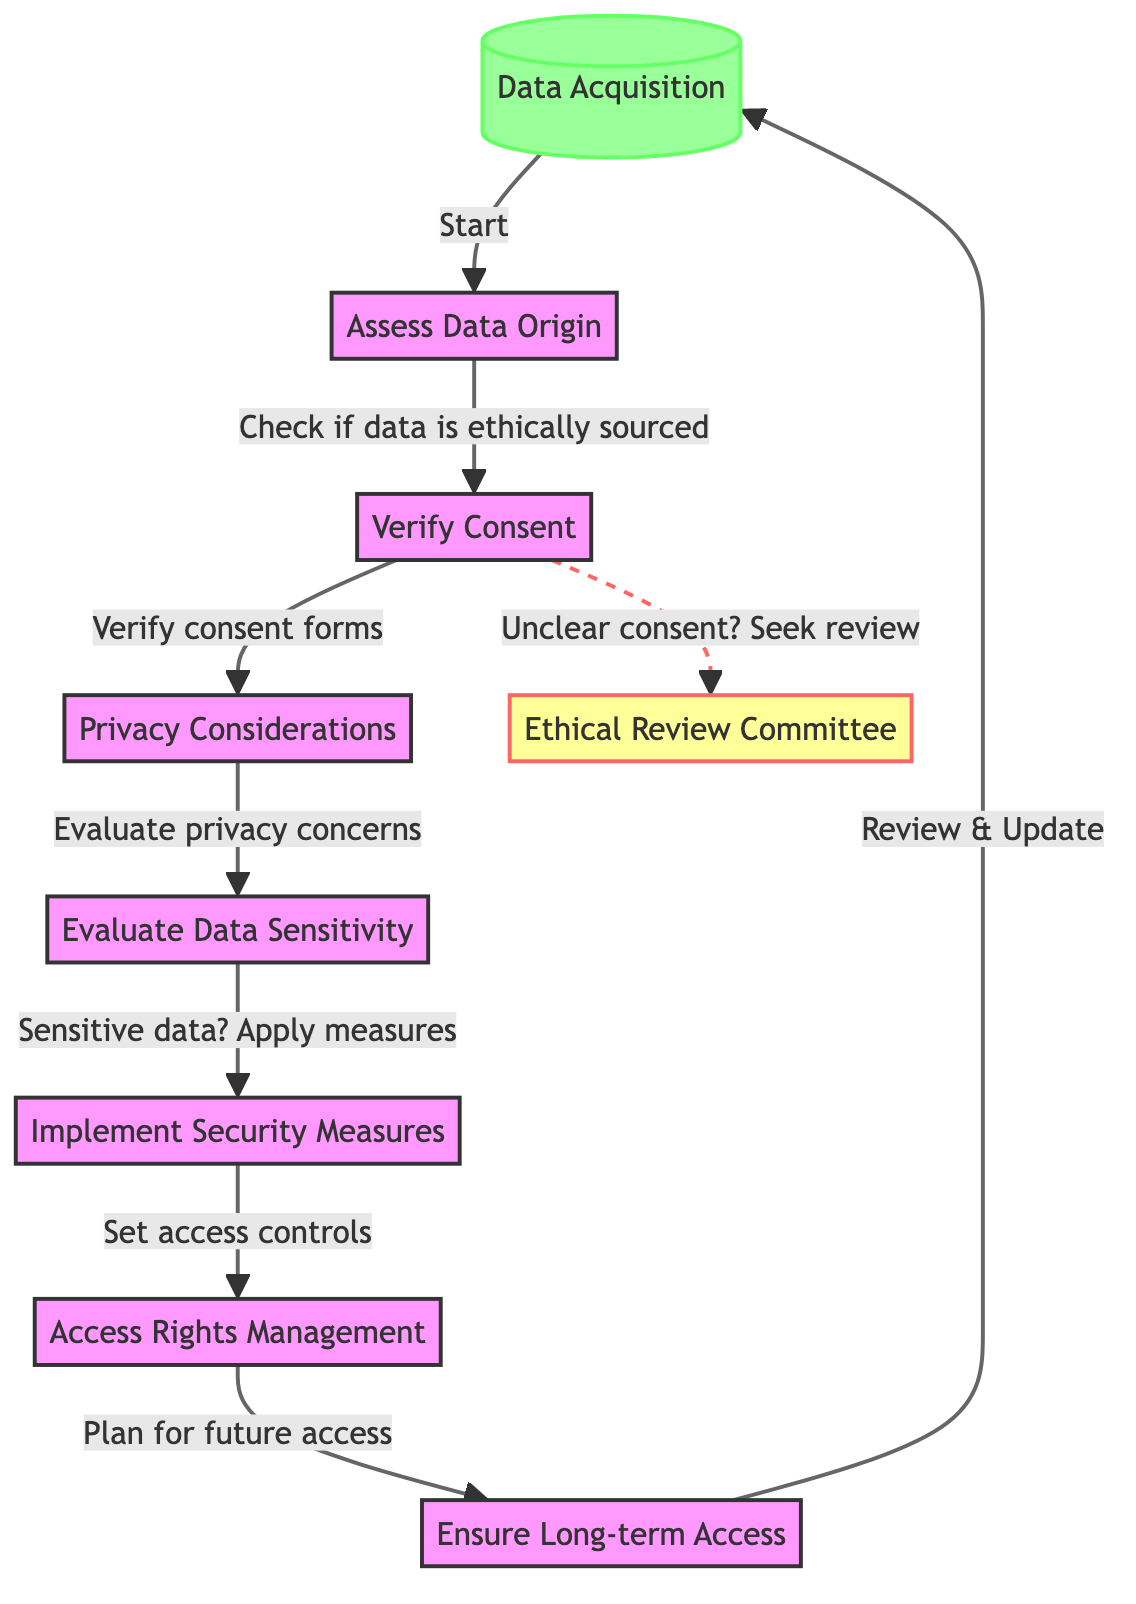What is the first step in the ethical decision-making process? The flowchart starts at the first node labeled "Data Acquisition", indicating it is the initial step in the ethical decision-making process.
Answer: Data Acquisition How many main nodes are there in the diagram? By counting the nodes, we see there are 8 main decision points, including the initial data acquisition step and various evaluations.
Answer: 8 What does the flow from "Verify Consent" lead to? From the node "Verify Consent," the flow directly leads to the node "Privacy Considerations," which emphasizes the importance of privacy after consent has been verified.
Answer: Privacy Considerations What happens if consent is unclear? If there is unclear consent, the diagram indicates a dashed line leading to the "Ethical Review Committee," suggesting a need for further evaluation by this committee before proceeding.
Answer: Seek review What is evaluated after assessing data origin? After "Assess Data Origin," the next step involves "Verify Consent," which highlights the importance of confirming that proper consent has been obtained for data use.
Answer: Verify Consent What kind of measures should be implemented for sensitive data? The flowchart indicates that after evaluating data sensitivity, "Implement Security Measures" should be enforced to protect sensitive information properly.
Answer: Implement Security Measures What is the last step indicated in the flowchart? The last step shown in the flowchart is "Review & Update," which loops back to "Data Acquisition," indicating an iterative process in ethical digital curation.
Answer: Review & Update How do you ensure data access post-evaluation? The diagram shows that after ensuring access rights management, the flow proceeds to "Ensure Long-term Access," signifying the consideration for future data accessibility.
Answer: Ensure Long-term Access 